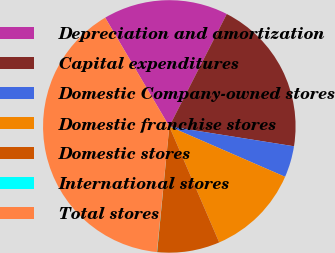<chart> <loc_0><loc_0><loc_500><loc_500><pie_chart><fcel>Depreciation and amortization<fcel>Capital expenditures<fcel>Domestic Company-owned stores<fcel>Domestic franchise stores<fcel>Domestic stores<fcel>International stores<fcel>Total stores<nl><fcel>16.0%<fcel>19.99%<fcel>4.02%<fcel>12.0%<fcel>8.01%<fcel>0.03%<fcel>39.95%<nl></chart> 